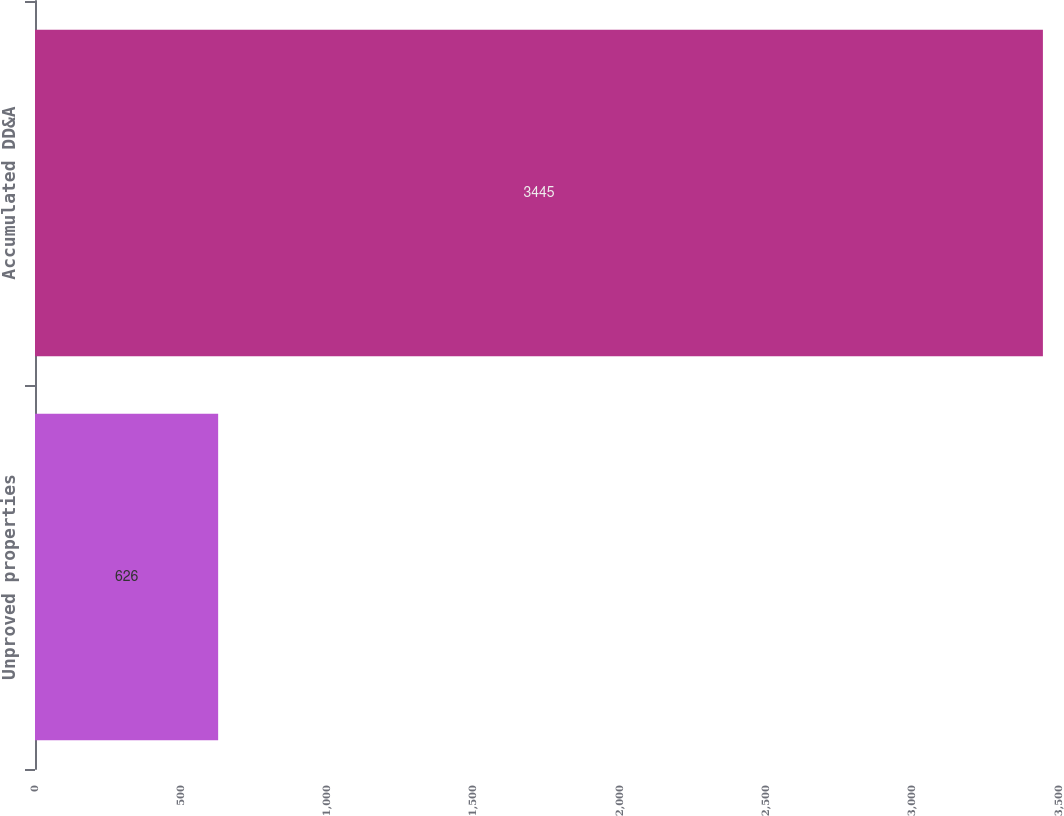<chart> <loc_0><loc_0><loc_500><loc_500><bar_chart><fcel>Unproved properties<fcel>Accumulated DD&A<nl><fcel>626<fcel>3445<nl></chart> 